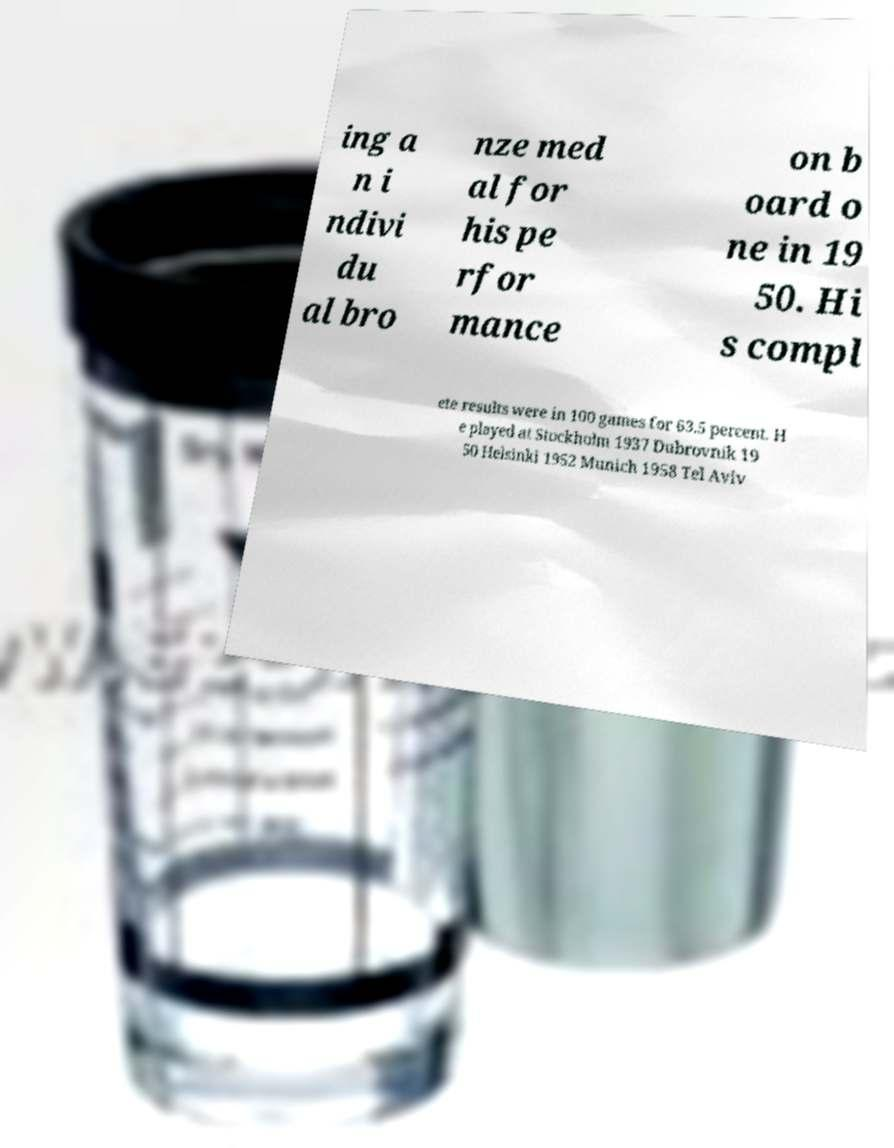Could you extract and type out the text from this image? ing a n i ndivi du al bro nze med al for his pe rfor mance on b oard o ne in 19 50. Hi s compl ete results were in 100 games for 63.5 percent. H e played at Stockholm 1937 Dubrovnik 19 50 Helsinki 1952 Munich 1958 Tel Aviv 